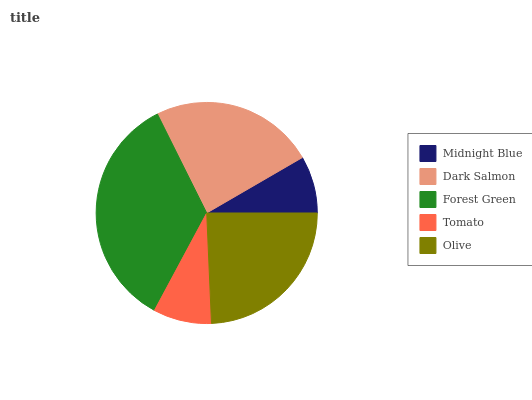Is Midnight Blue the minimum?
Answer yes or no. Yes. Is Forest Green the maximum?
Answer yes or no. Yes. Is Dark Salmon the minimum?
Answer yes or no. No. Is Dark Salmon the maximum?
Answer yes or no. No. Is Dark Salmon greater than Midnight Blue?
Answer yes or no. Yes. Is Midnight Blue less than Dark Salmon?
Answer yes or no. Yes. Is Midnight Blue greater than Dark Salmon?
Answer yes or no. No. Is Dark Salmon less than Midnight Blue?
Answer yes or no. No. Is Dark Salmon the high median?
Answer yes or no. Yes. Is Dark Salmon the low median?
Answer yes or no. Yes. Is Tomato the high median?
Answer yes or no. No. Is Midnight Blue the low median?
Answer yes or no. No. 